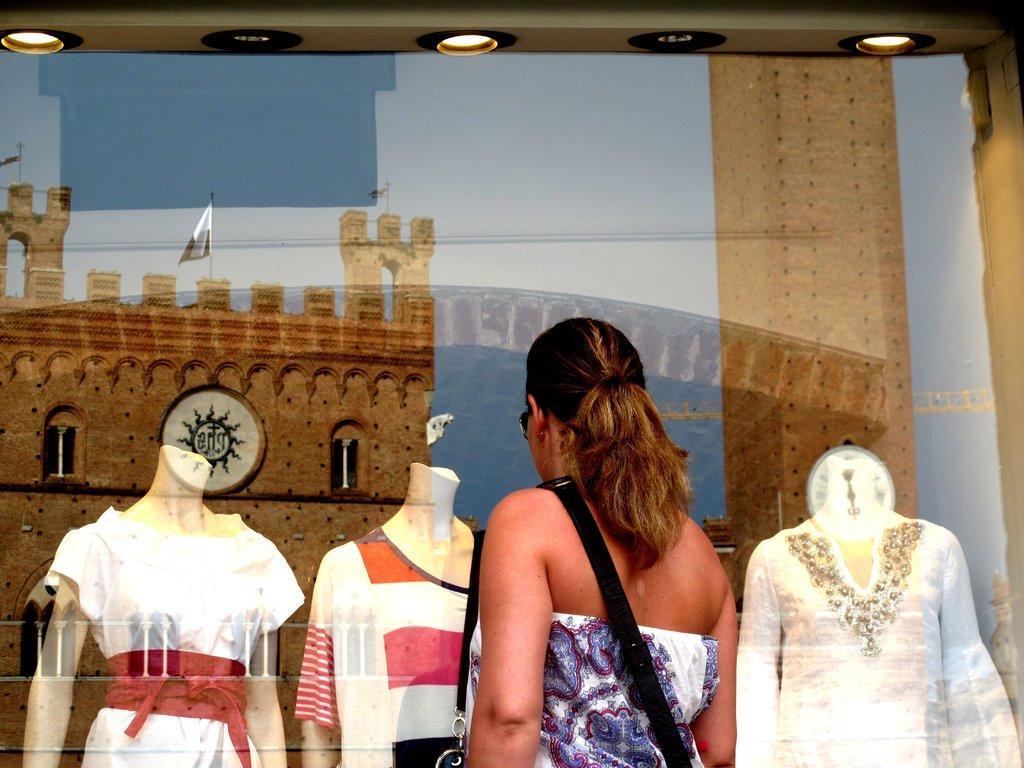Describe this image in one or two sentences. In this image there is a person standing , and there are mannequins with dresses , there are lights, there is a reflection of a fort , flags with the poles, and there is sky. 